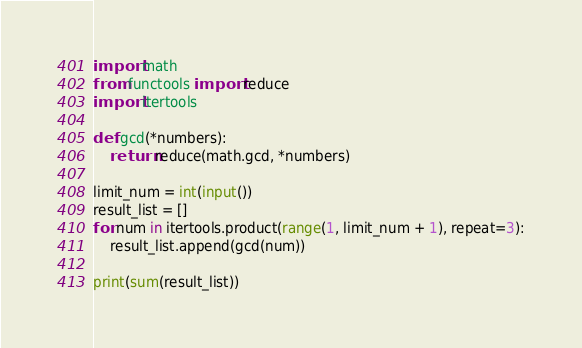Convert code to text. <code><loc_0><loc_0><loc_500><loc_500><_Python_>import math
from functools import reduce
import itertools

def gcd(*numbers):
	return reduce(math.gcd, *numbers)

limit_num = int(input())
result_list = []
for num in itertools.product(range(1, limit_num + 1), repeat=3):
	result_list.append(gcd(num))

print(sum(result_list))
</code> 